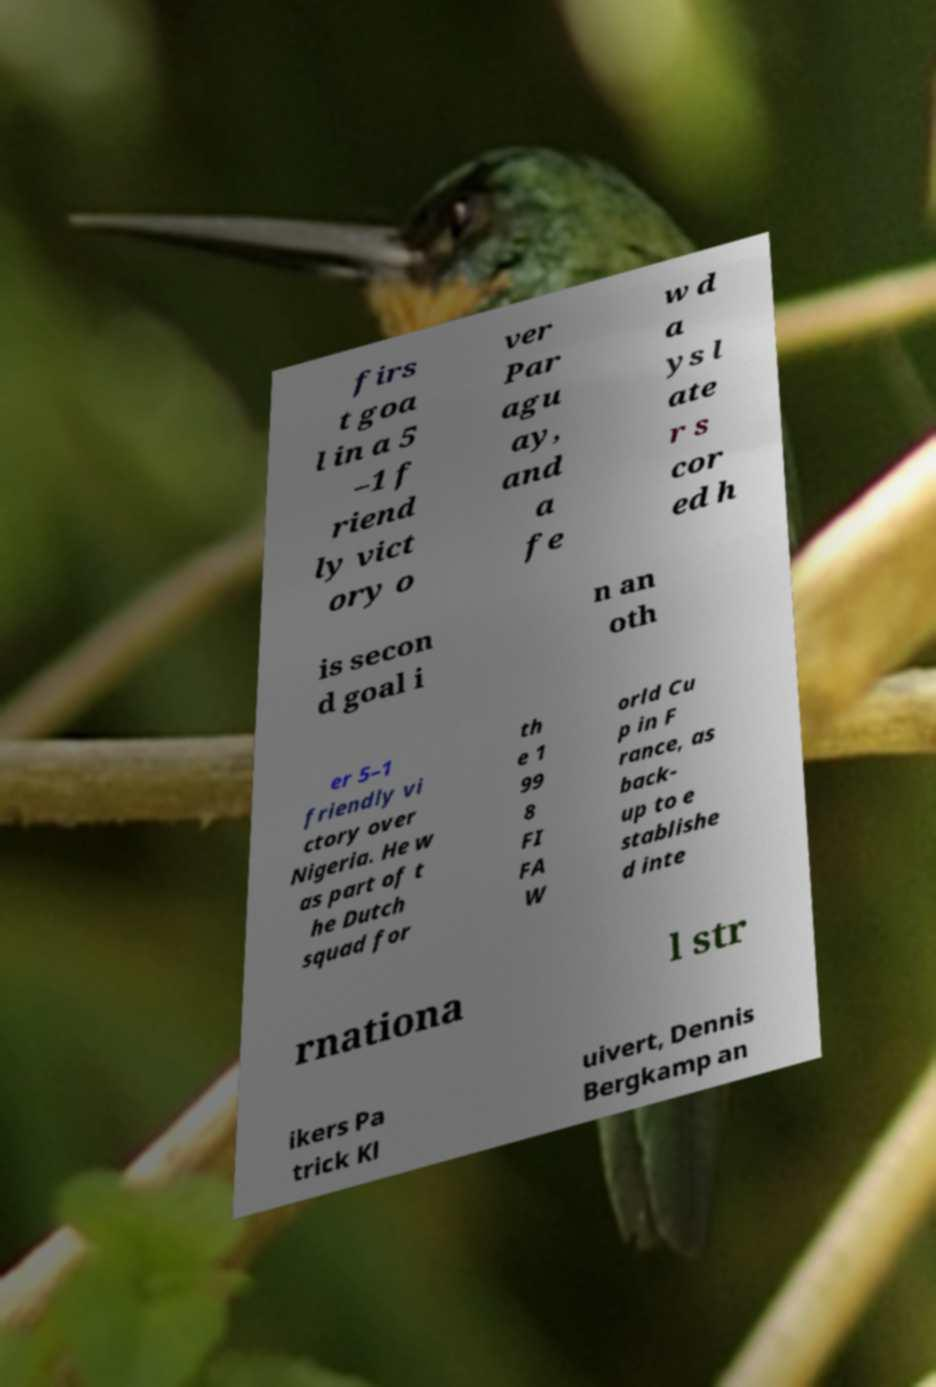I need the written content from this picture converted into text. Can you do that? firs t goa l in a 5 –1 f riend ly vict ory o ver Par agu ay, and a fe w d a ys l ate r s cor ed h is secon d goal i n an oth er 5–1 friendly vi ctory over Nigeria. He w as part of t he Dutch squad for th e 1 99 8 FI FA W orld Cu p in F rance, as back- up to e stablishe d inte rnationa l str ikers Pa trick Kl uivert, Dennis Bergkamp an 